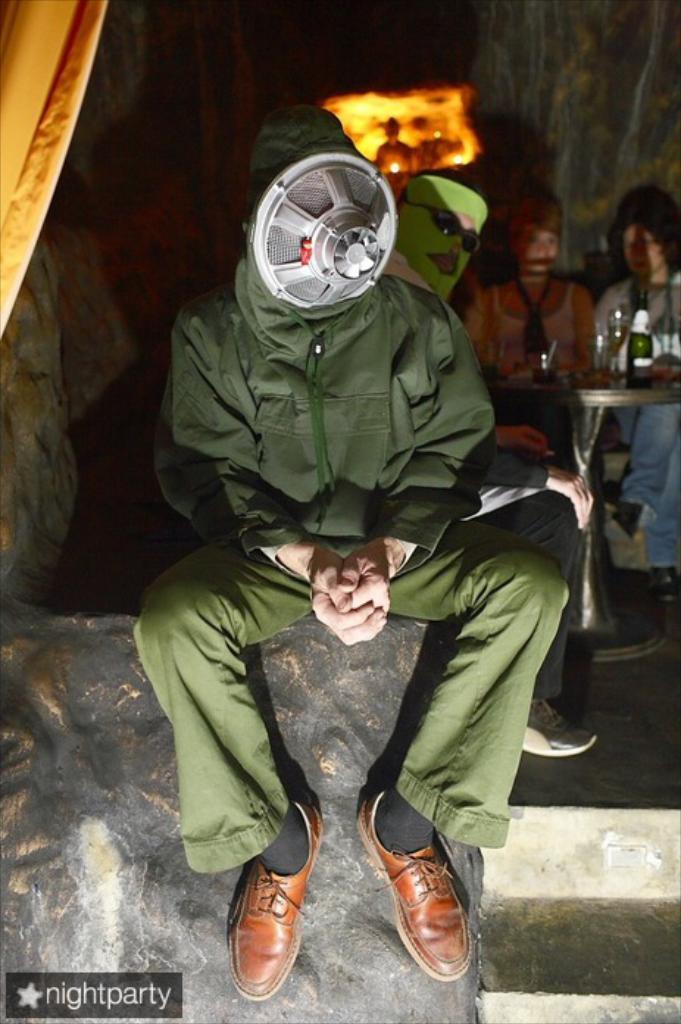Please provide a concise description of this image. In this image we can see some people sitting. In that two men are wearing the mask. We can also see a staircase, light and a table containing some glasses and a bottle on it. 